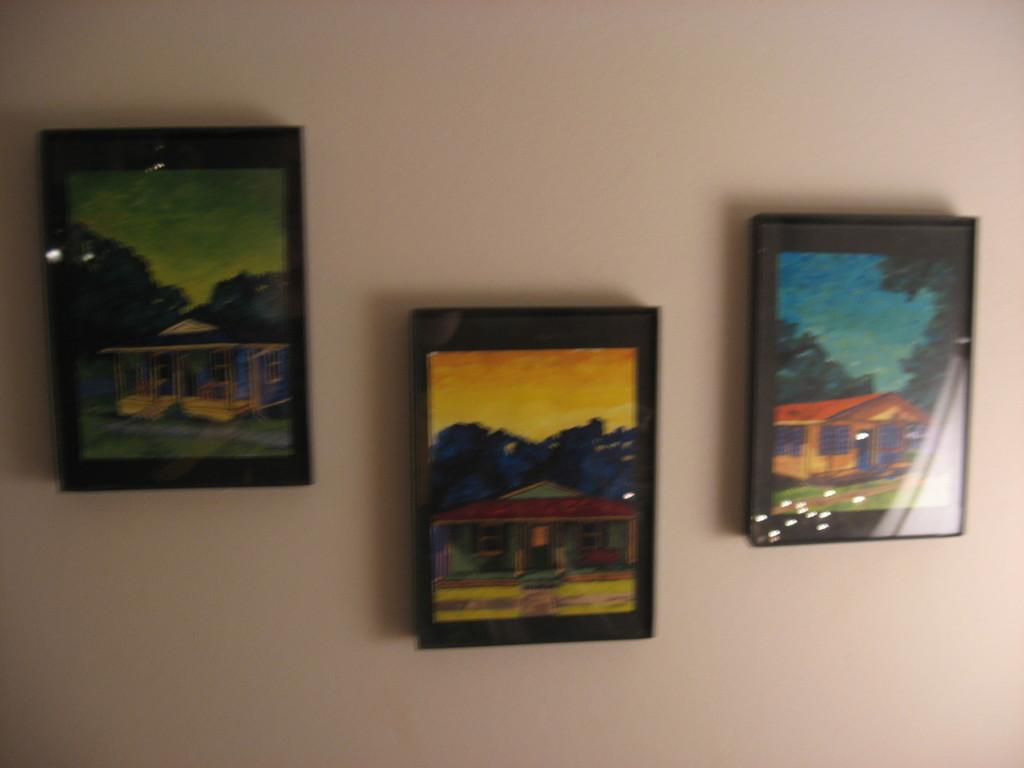What objects are present in the image that are used for displaying photos? There are photo frames in the image. Where are the photo frames located in the image? The photo frames are attached to the wall. What type of straw is used to decorate the photo frames in the image? There is no straw present in the image; it only features photo frames attached to the wall. 